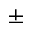Convert formula to latex. <formula><loc_0><loc_0><loc_500><loc_500>\pm</formula> 